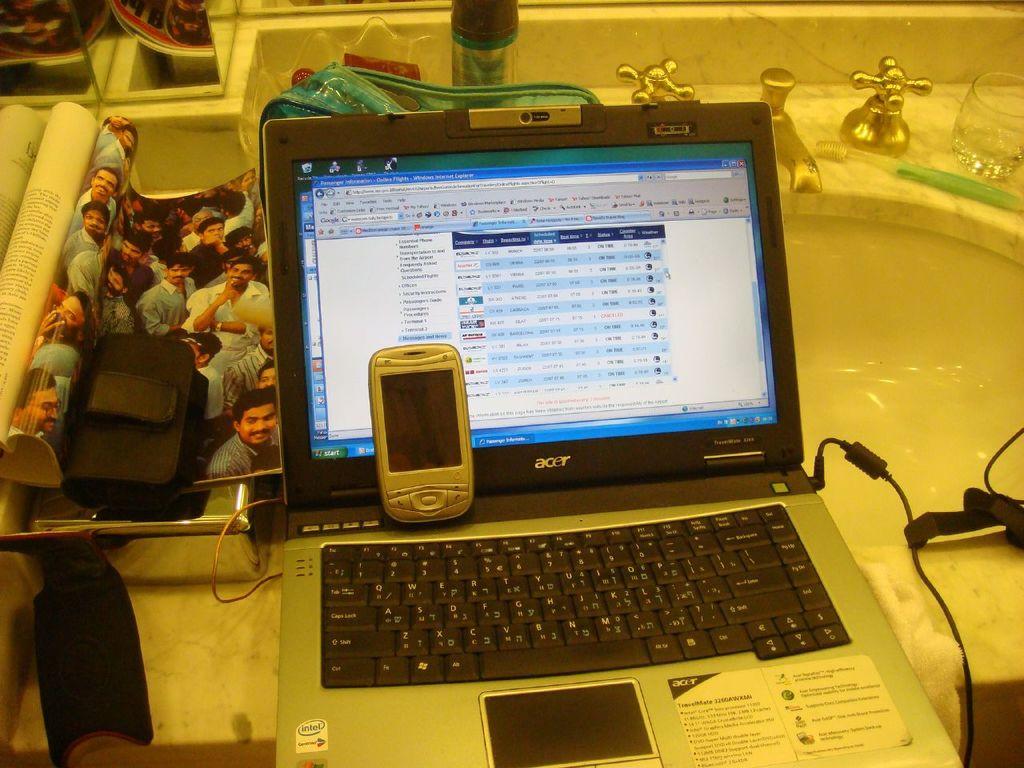What brand is the laptop?
Offer a terse response. Acer. What is the laptop brand?
Give a very brief answer. Acer. 